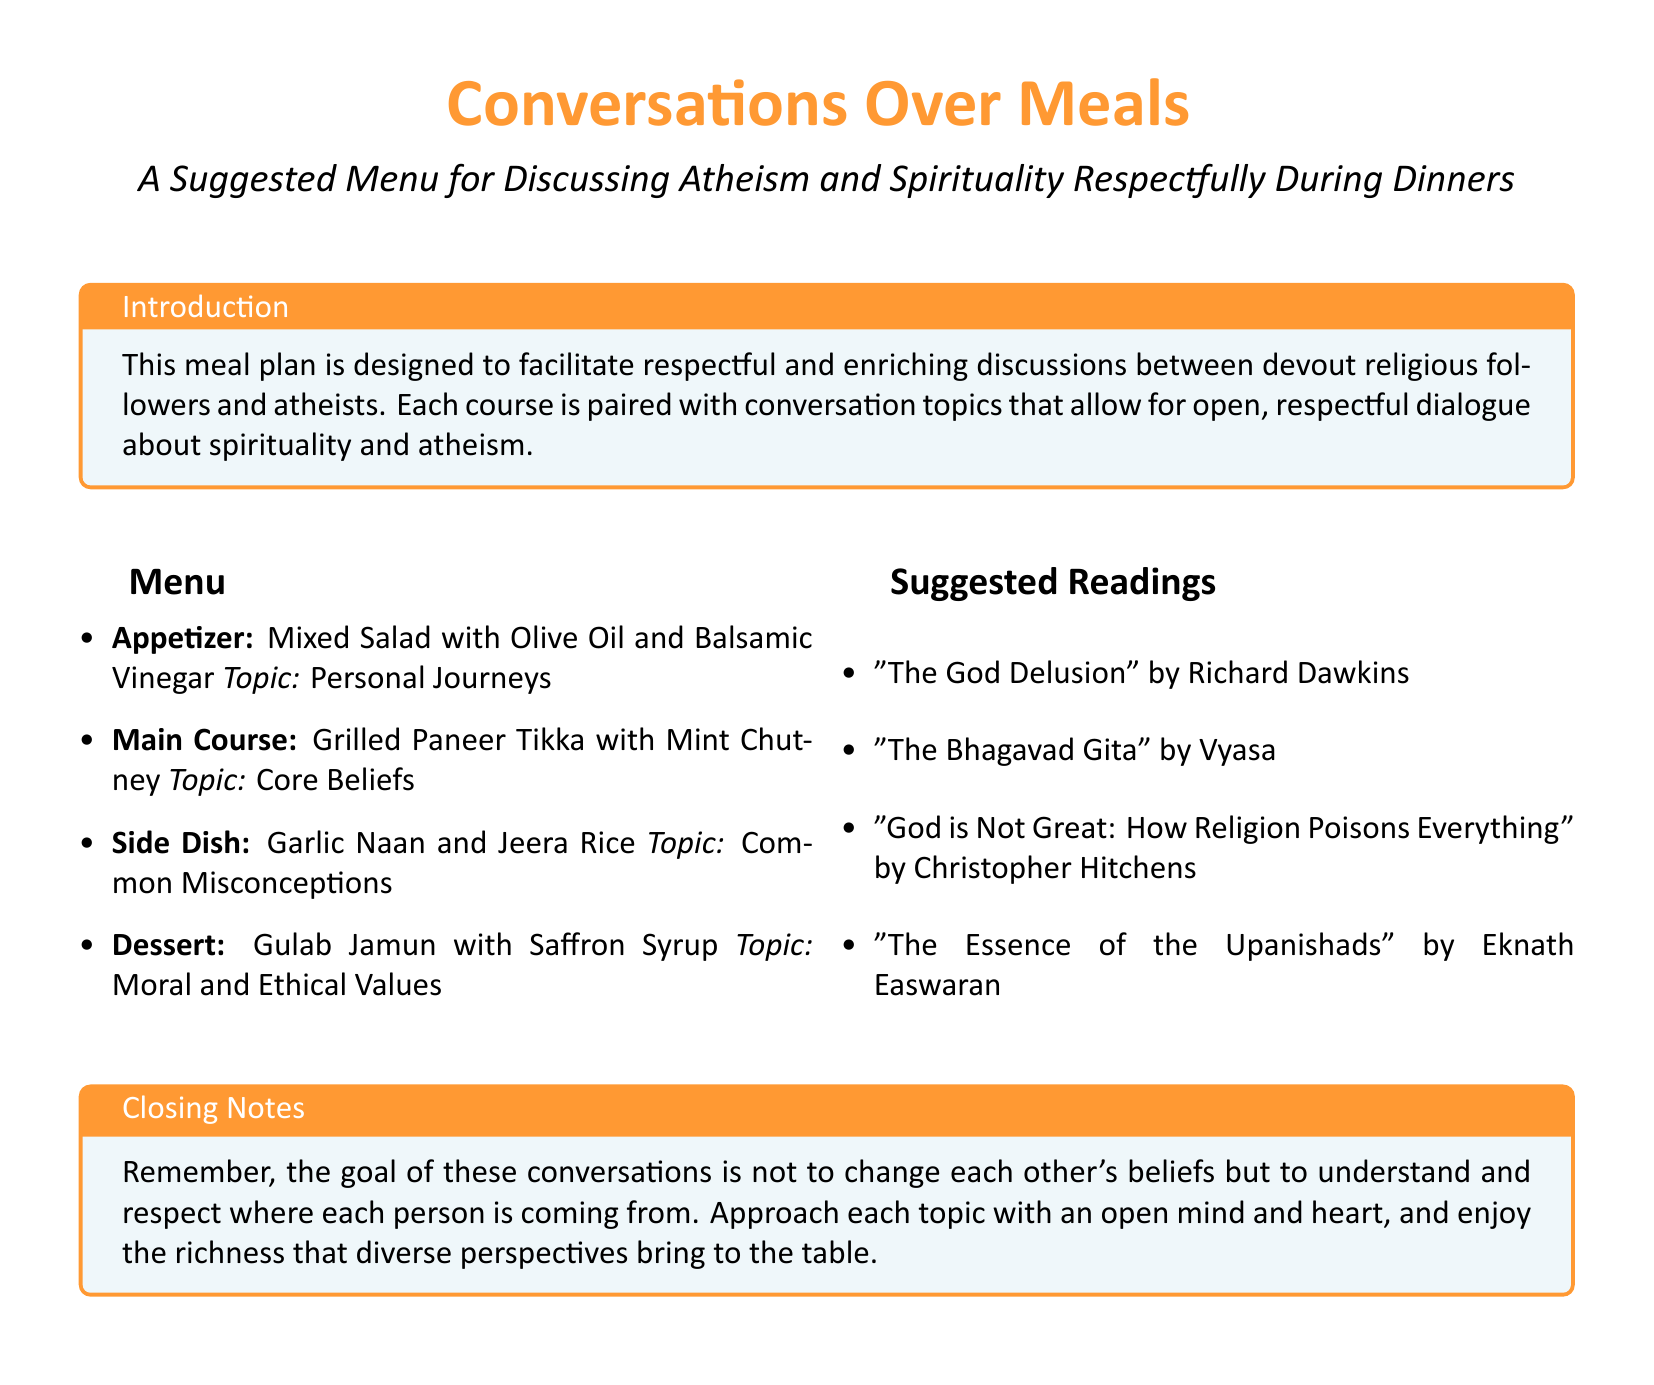What is the appetizer for the meal plan? The appetizer is specifically mentioned in the document as Mixed Salad with Olive Oil and Balsamic Vinegar.
Answer: Mixed Salad with Olive Oil and Balsamic Vinegar What is the main topic for the main course discussion? The document states the main topic for the main course is Core Beliefs, paired with Grilled Paneer Tikka.
Answer: Core Beliefs Which dessert is included in the suggested menu? The document clearly lists Gulab Jamun with Saffron Syrup as the dessert in the suggested menu.
Answer: Gulab Jamun with Saffron Syrup How many suggested readings are listed? By counting the entries in the suggested readings section, we find that there are four titles mentioned.
Answer: 4 What is the purpose of the meal plan? The document indicates that the meal plan is designed to facilitate respectful and enriching discussions between devout religious followers and atheists.
Answer: Facilitate respectful discussions What side dish accompanies the main course? According to the document, Garlic Naan and Jeera Rice are listed as the side dish accompanying the main course.
Answer: Garlic Naan and Jeera Rice Who is the author of "The God Delusion"? The document attributes "The God Delusion" to Richard Dawkins.
Answer: Richard Dawkins What is the overall goal of the conversations? The closing notes state that the goal is to understand and respect different beliefs.
Answer: Understand and respect beliefs 